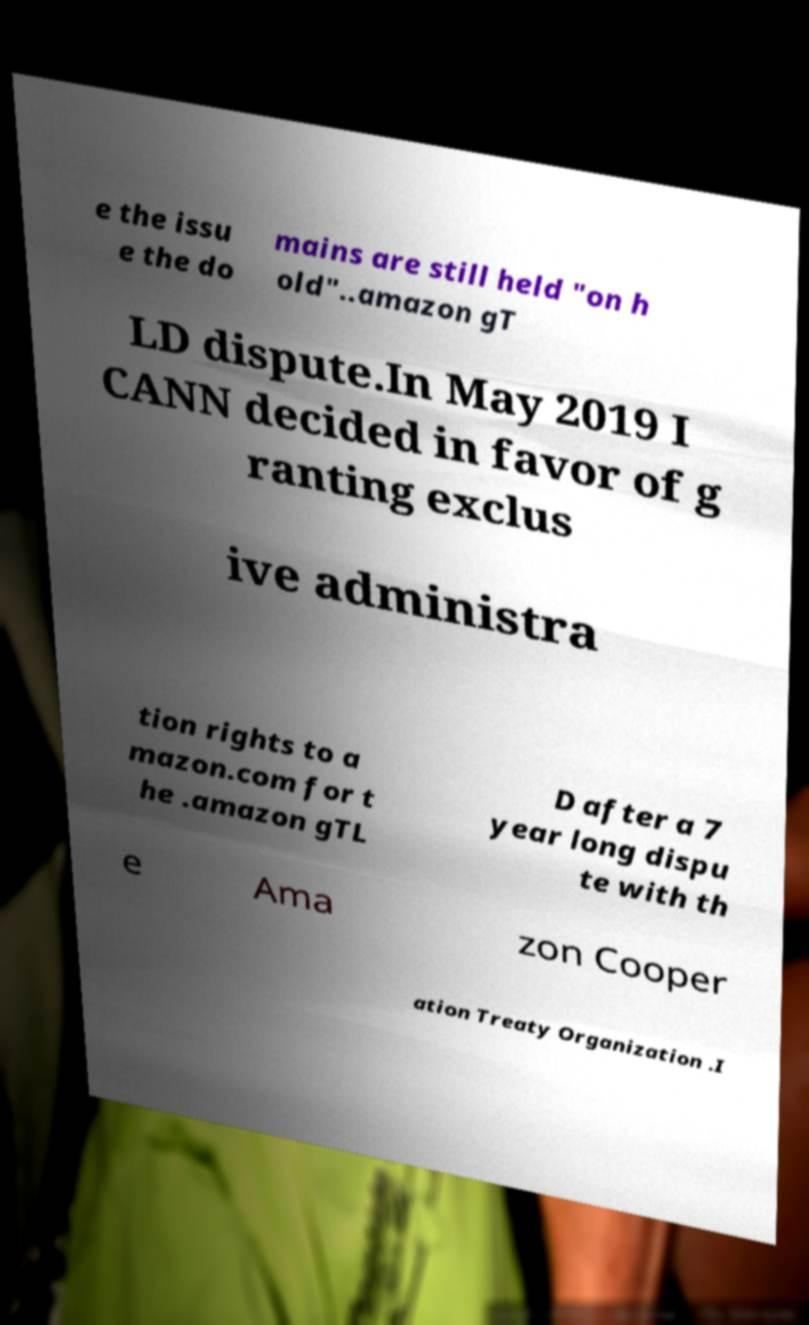Please read and relay the text visible in this image. What does it say? e the issu e the do mains are still held "on h old"..amazon gT LD dispute.In May 2019 I CANN decided in favor of g ranting exclus ive administra tion rights to a mazon.com for t he .amazon gTL D after a 7 year long dispu te with th e Ama zon Cooper ation Treaty Organization .I 